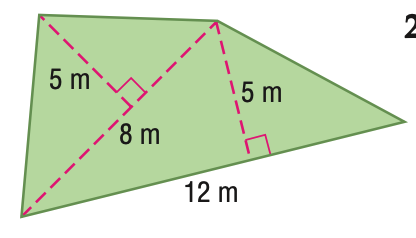Answer the mathemtical geometry problem and directly provide the correct option letter.
Question: Find the area of the figure. Round to the nearest tenth if necessary.
Choices: A: 40 B: 50 C: 60 D: 80 B 